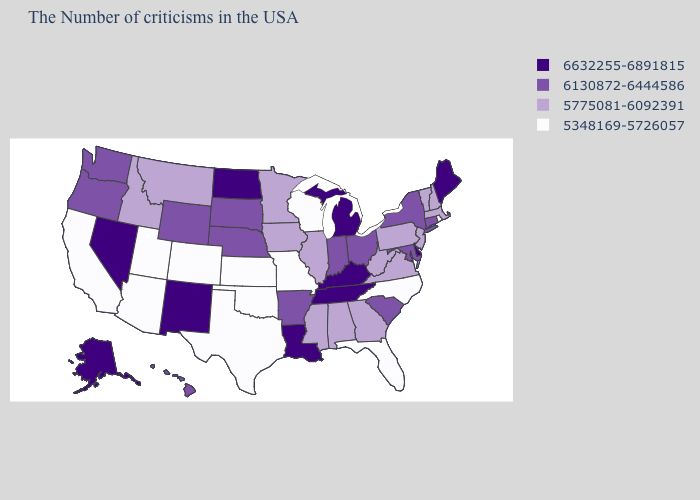What is the highest value in the USA?
Be succinct. 6632255-6891815. Name the states that have a value in the range 6130872-6444586?
Quick response, please. Connecticut, New York, Maryland, South Carolina, Ohio, Indiana, Arkansas, Nebraska, South Dakota, Wyoming, Washington, Oregon, Hawaii. What is the value of Massachusetts?
Answer briefly. 5775081-6092391. Name the states that have a value in the range 5775081-6092391?
Keep it brief. Massachusetts, New Hampshire, Vermont, New Jersey, Pennsylvania, Virginia, West Virginia, Georgia, Alabama, Illinois, Mississippi, Minnesota, Iowa, Montana, Idaho. Among the states that border Alabama , which have the highest value?
Keep it brief. Tennessee. Does Arizona have the lowest value in the USA?
Keep it brief. Yes. What is the highest value in the MidWest ?
Short answer required. 6632255-6891815. Name the states that have a value in the range 6130872-6444586?
Be succinct. Connecticut, New York, Maryland, South Carolina, Ohio, Indiana, Arkansas, Nebraska, South Dakota, Wyoming, Washington, Oregon, Hawaii. Name the states that have a value in the range 5348169-5726057?
Quick response, please. Rhode Island, North Carolina, Florida, Wisconsin, Missouri, Kansas, Oklahoma, Texas, Colorado, Utah, Arizona, California. What is the value of Utah?
Write a very short answer. 5348169-5726057. What is the value of Mississippi?
Keep it brief. 5775081-6092391. Which states have the lowest value in the USA?
Concise answer only. Rhode Island, North Carolina, Florida, Wisconsin, Missouri, Kansas, Oklahoma, Texas, Colorado, Utah, Arizona, California. Name the states that have a value in the range 5775081-6092391?
Short answer required. Massachusetts, New Hampshire, Vermont, New Jersey, Pennsylvania, Virginia, West Virginia, Georgia, Alabama, Illinois, Mississippi, Minnesota, Iowa, Montana, Idaho. Name the states that have a value in the range 6632255-6891815?
Keep it brief. Maine, Delaware, Michigan, Kentucky, Tennessee, Louisiana, North Dakota, New Mexico, Nevada, Alaska. Does the first symbol in the legend represent the smallest category?
Quick response, please. No. 